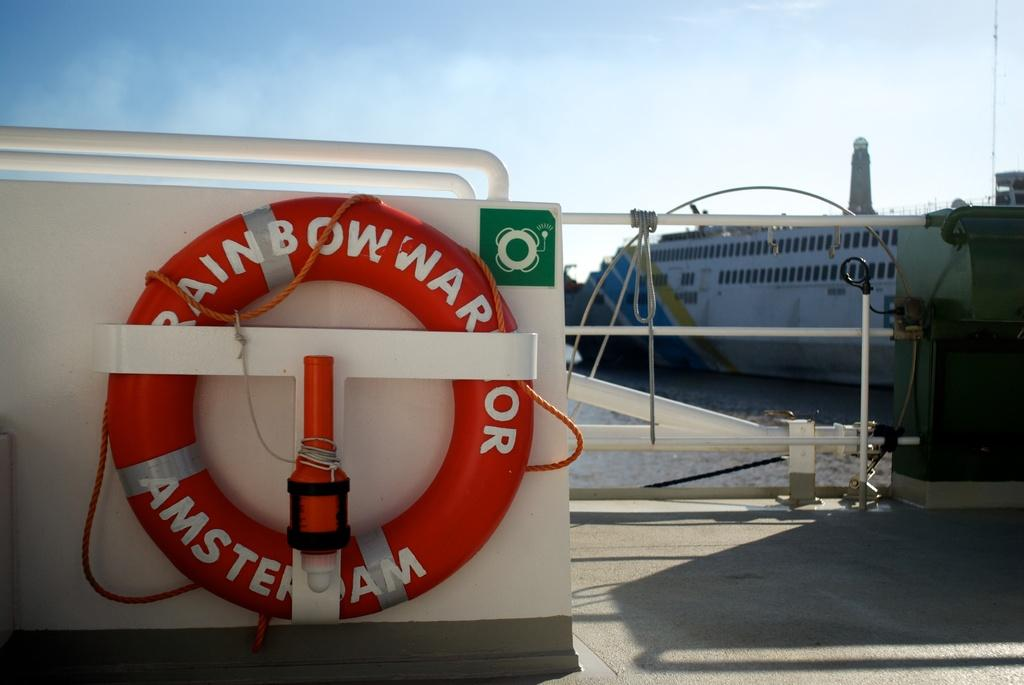<image>
Provide a brief description of the given image. I boat with a life saver ring labeled Rainbow War Amsterdam. 